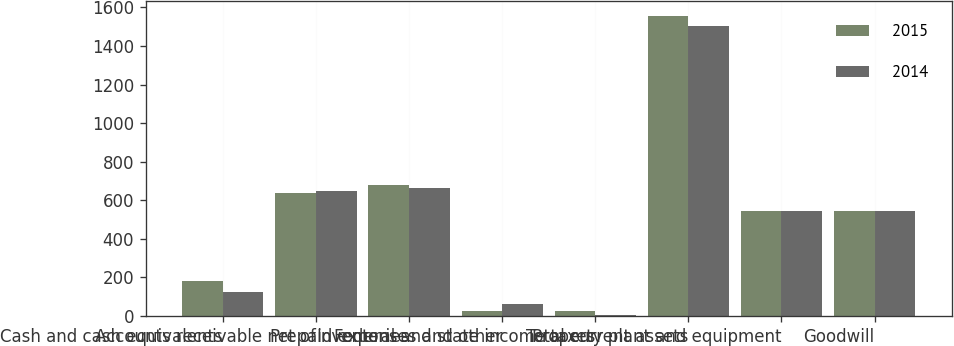<chart> <loc_0><loc_0><loc_500><loc_500><stacked_bar_chart><ecel><fcel>Cash and cash equivalents<fcel>Accounts receivable net of<fcel>Inventories<fcel>Prepaid expenses and other<fcel>Federal and state income taxes<fcel>Total current assets<fcel>Property plant and equipment<fcel>Goodwill<nl><fcel>2015<fcel>184.2<fcel>636.5<fcel>676.8<fcel>28.8<fcel>28.2<fcel>1554.5<fcel>545.4<fcel>544<nl><fcel>2014<fcel>124.9<fcel>646.1<fcel>664.9<fcel>61.9<fcel>5.1<fcel>1502.9<fcel>545.4<fcel>546.8<nl></chart> 